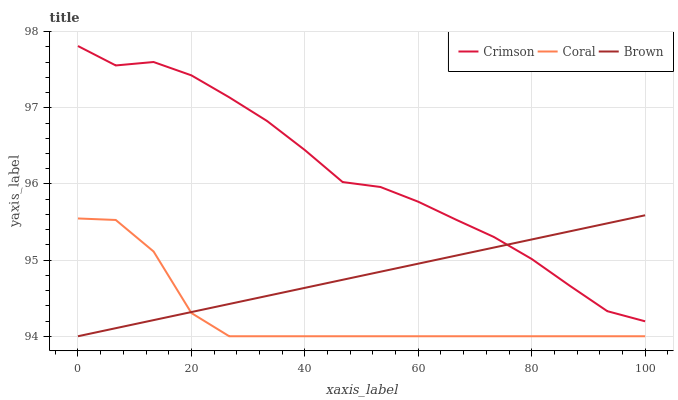Does Coral have the minimum area under the curve?
Answer yes or no. Yes. Does Crimson have the maximum area under the curve?
Answer yes or no. Yes. Does Brown have the minimum area under the curve?
Answer yes or no. No. Does Brown have the maximum area under the curve?
Answer yes or no. No. Is Brown the smoothest?
Answer yes or no. Yes. Is Crimson the roughest?
Answer yes or no. Yes. Is Coral the smoothest?
Answer yes or no. No. Is Coral the roughest?
Answer yes or no. No. Does Crimson have the highest value?
Answer yes or no. Yes. Does Brown have the highest value?
Answer yes or no. No. Is Coral less than Crimson?
Answer yes or no. Yes. Is Crimson greater than Coral?
Answer yes or no. Yes. Does Brown intersect Crimson?
Answer yes or no. Yes. Is Brown less than Crimson?
Answer yes or no. No. Is Brown greater than Crimson?
Answer yes or no. No. Does Coral intersect Crimson?
Answer yes or no. No. 